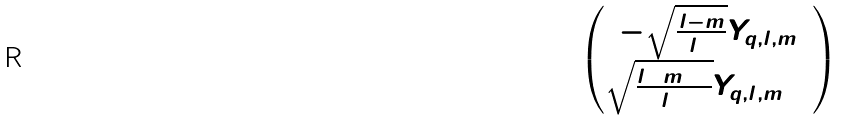Convert formula to latex. <formula><loc_0><loc_0><loc_500><loc_500>\begin{pmatrix} - \sqrt { \frac { l - m } { 2 l + 1 } } Y _ { q , l , m } \\ \sqrt { \frac { l + m + 1 } { 2 l + 1 } } Y _ { q , l , m + 1 } \end{pmatrix}</formula> 